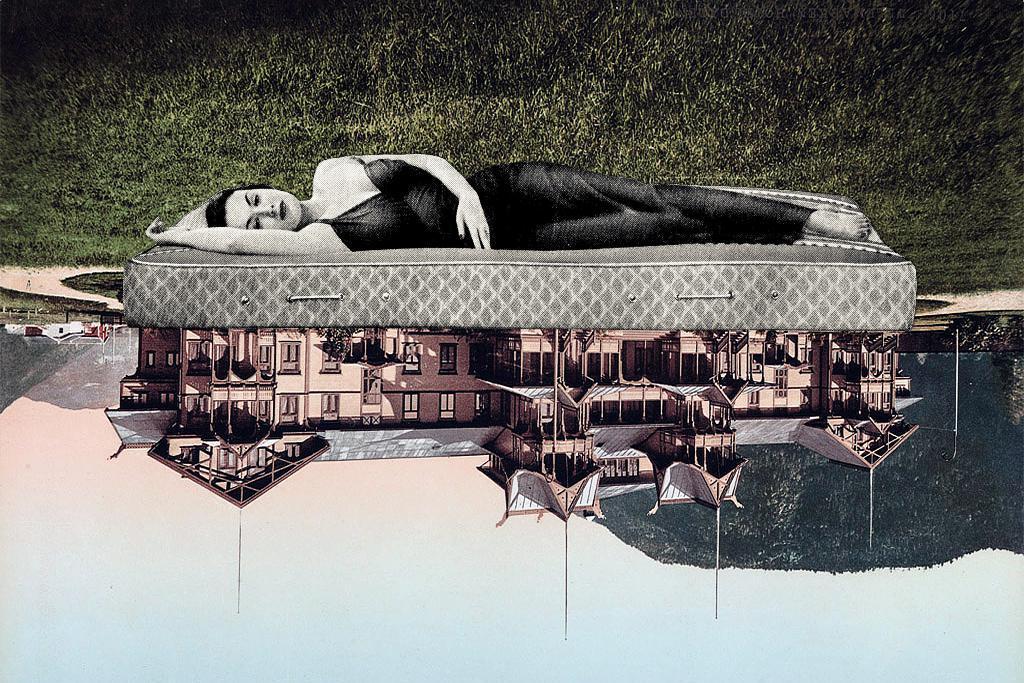Could you give a brief overview of what you see in this image? This picture shows a graphical image, we see reflection of a Building in water and a woman sleeping on the bed and i can see grass. 